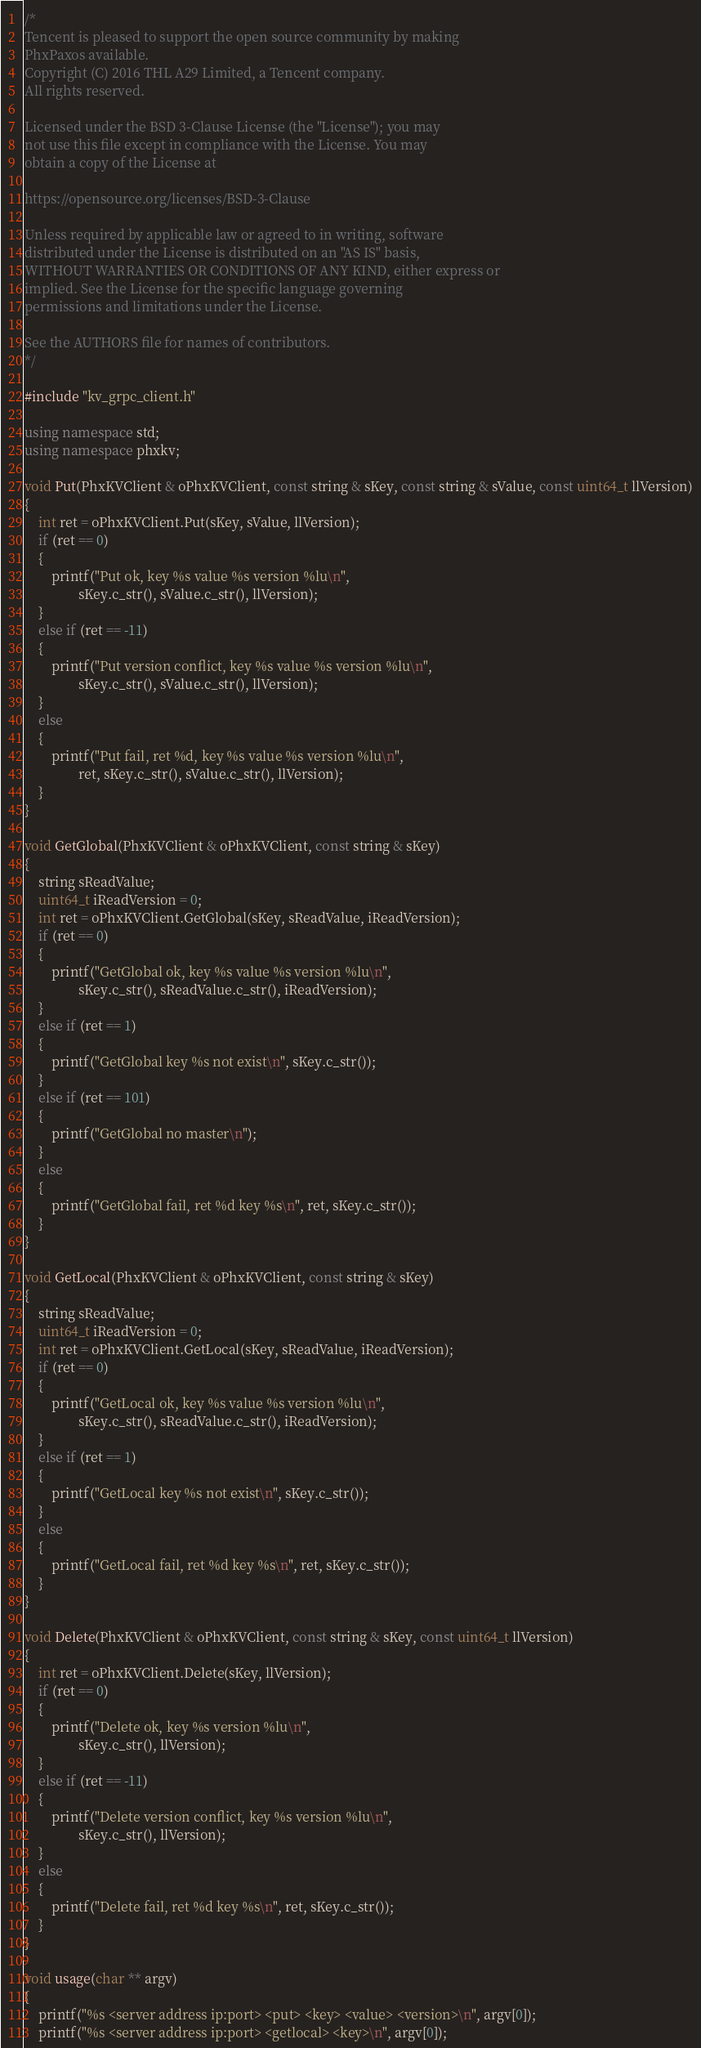<code> <loc_0><loc_0><loc_500><loc_500><_C++_>/*
Tencent is pleased to support the open source community by making 
PhxPaxos available.
Copyright (C) 2016 THL A29 Limited, a Tencent company. 
All rights reserved.

Licensed under the BSD 3-Clause License (the "License"); you may 
not use this file except in compliance with the License. You may 
obtain a copy of the License at

https://opensource.org/licenses/BSD-3-Clause

Unless required by applicable law or agreed to in writing, software 
distributed under the License is distributed on an "AS IS" basis, 
WITHOUT WARRANTIES OR CONDITIONS OF ANY KIND, either express or 
implied. See the License for the specific language governing 
permissions and limitations under the License.

See the AUTHORS file for names of contributors. 
*/

#include "kv_grpc_client.h"

using namespace std;
using namespace phxkv;

void Put(PhxKVClient & oPhxKVClient, const string & sKey, const string & sValue, const uint64_t llVersion)
{
    int ret = oPhxKVClient.Put(sKey, sValue, llVersion);
    if (ret == 0)
    {
        printf("Put ok, key %s value %s version %lu\n", 
                sKey.c_str(), sValue.c_str(), llVersion);
    }
    else if (ret == -11)
    {
        printf("Put version conflict, key %s value %s version %lu\n",
                sKey.c_str(), sValue.c_str(), llVersion);
    }
    else
    {
        printf("Put fail, ret %d, key %s value %s version %lu\n", 
                ret, sKey.c_str(), sValue.c_str(), llVersion);
    }
}

void GetGlobal(PhxKVClient & oPhxKVClient, const string & sKey)
{
    string sReadValue;
    uint64_t iReadVersion = 0;
    int ret = oPhxKVClient.GetGlobal(sKey, sReadValue, iReadVersion);
    if (ret == 0)
    {
        printf("GetGlobal ok, key %s value %s version %lu\n", 
                sKey.c_str(), sReadValue.c_str(), iReadVersion);
    }
    else if (ret == 1)
    {
        printf("GetGlobal key %s not exist\n", sKey.c_str());
    }
    else if (ret == 101)
    {
        printf("GetGlobal no master\n");
    }
    else
    {
        printf("GetGlobal fail, ret %d key %s\n", ret, sKey.c_str());
    }
}

void GetLocal(PhxKVClient & oPhxKVClient, const string & sKey)
{
    string sReadValue;
    uint64_t iReadVersion = 0;
    int ret = oPhxKVClient.GetLocal(sKey, sReadValue, iReadVersion);
    if (ret == 0)
    {
        printf("GetLocal ok, key %s value %s version %lu\n", 
                sKey.c_str(), sReadValue.c_str(), iReadVersion);
    }
    else if (ret == 1)
    {
        printf("GetLocal key %s not exist\n", sKey.c_str());
    }
    else
    {
        printf("GetLocal fail, ret %d key %s\n", ret, sKey.c_str());
    }
}

void Delete(PhxKVClient & oPhxKVClient, const string & sKey, const uint64_t llVersion)
{
    int ret = oPhxKVClient.Delete(sKey, llVersion);
    if (ret == 0)
    {
        printf("Delete ok, key %s version %lu\n", 
                sKey.c_str(), llVersion);
    }
    else if (ret == -11)
    {
        printf("Delete version conflict, key %s version %lu\n", 
                sKey.c_str(), llVersion);
    }
    else
    {
        printf("Delete fail, ret %d key %s\n", ret, sKey.c_str());
    }
}

void usage(char ** argv)
{
    printf("%s <server address ip:port> <put> <key> <value> <version>\n", argv[0]);
    printf("%s <server address ip:port> <getlocal> <key>\n", argv[0]);</code> 